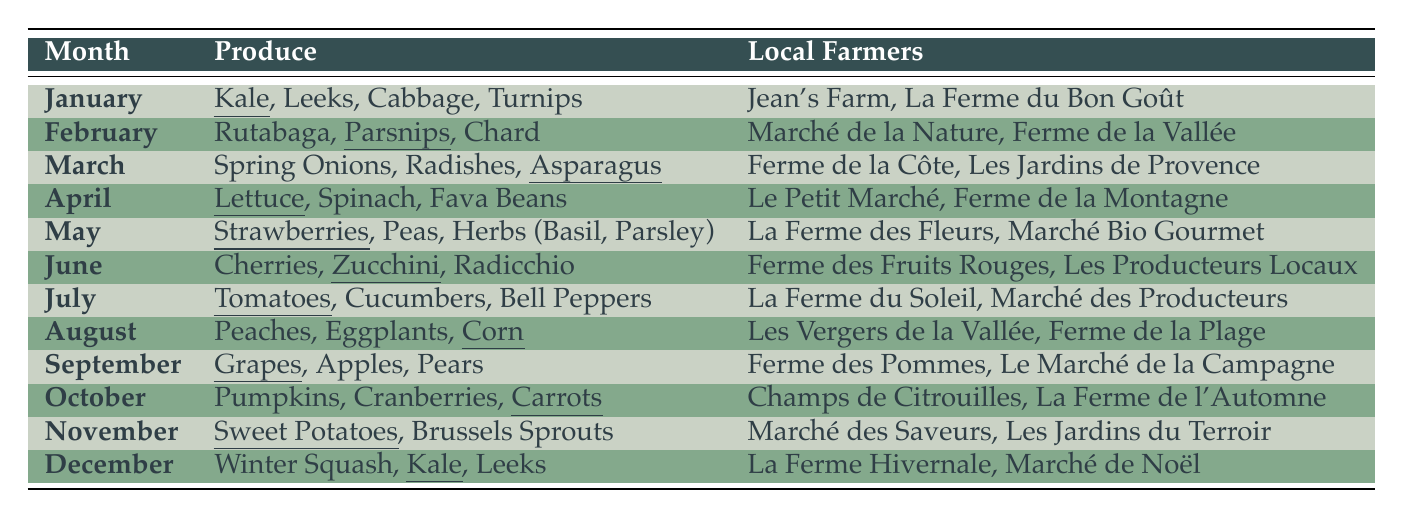What produce is available in June? The table shows that in June, the available produce includes Cherries, Zucchini, and Radicchio.
Answer: Cherries, Zucchini, Radicchio Which month has Sweet Potatoes as produce? By looking through the table, Sweet Potatoes are listed under the month of November.
Answer: November How many types of produce are listed for October? In the table, the produce for October includes Pumpkins, Cranberries, and Carrots, which totals three types.
Answer: 3 Is Kale available in December? The table states that Kale is indeed listed as a type of produce available in December.
Answer: Yes Which local farmers are associated with May's produce? The farmers listed for May are La Ferme des Fleurs and Marché Bio Gourmet.
Answer: La Ferme des Fleurs, Marché Bio Gourmet What is the total number of unique types of produce listed across the whole year? Adding up all the unique types from each month, we have Kale, Leeks, Cabbage, Turnips, Rutabaga, Parsnips, Chard, Spring Onions, Radishes, Asparagus, Lettuce, Spinach, Fava Beans, Strawberries, Peas, Herbs, Cherries, Zucchini, Radicchio, Tomatoes, Cucumbers, Bell Peppers, Peaches, Eggplants, Corn, Grapes, Apples, Pears, Pumpkins, Cranberries, Carrots, Sweet Potatoes, Brussels Sprouts, Winter Squash, which gives a total of 33 unique types.
Answer: 33 In which month can you find both Radishes and Lettuce? Referring to the table, Radishes are available in March, and Lettuce is available in April, meaning there is no month with both, so the answer is no.
Answer: No What are the top three months for fruit availability? The months with the most distinct fruit types are May (Strawberries), June (Cherries), and August (Peaches). This suggests that these months may be the fruit densest.
Answer: May, June, August How many local farmers sell produce in January? The table indicates that there are two local farmers selling produce in January: Jean's Farm and La Ferme du Bon Goût.
Answer: 2 Which month has the maximum number of local farmers, and how many are there? Upon reviewing the table, it shows that May and August have two farmers each, which is less than others, but all months have two farmers.
Answer: All months have 2 farmers 